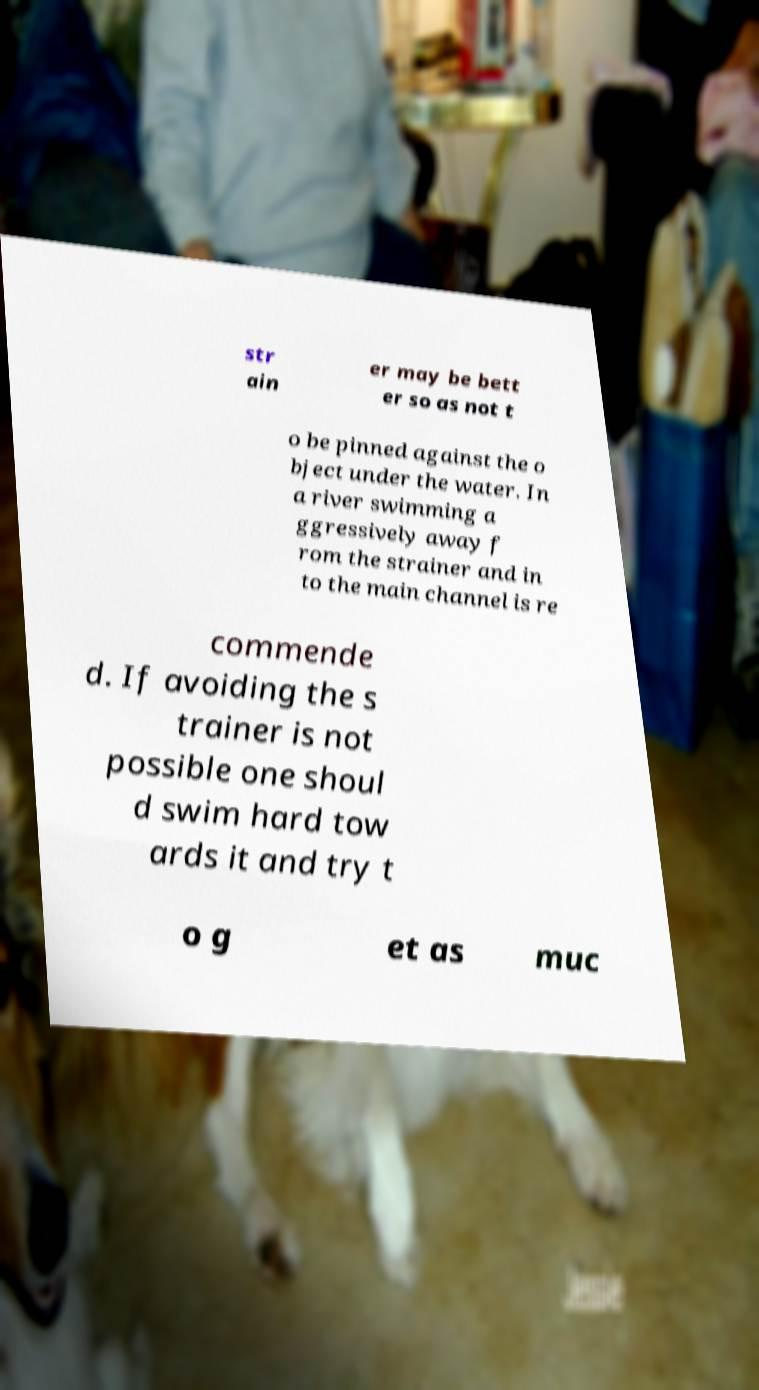Can you accurately transcribe the text from the provided image for me? str ain er may be bett er so as not t o be pinned against the o bject under the water. In a river swimming a ggressively away f rom the strainer and in to the main channel is re commende d. If avoiding the s trainer is not possible one shoul d swim hard tow ards it and try t o g et as muc 